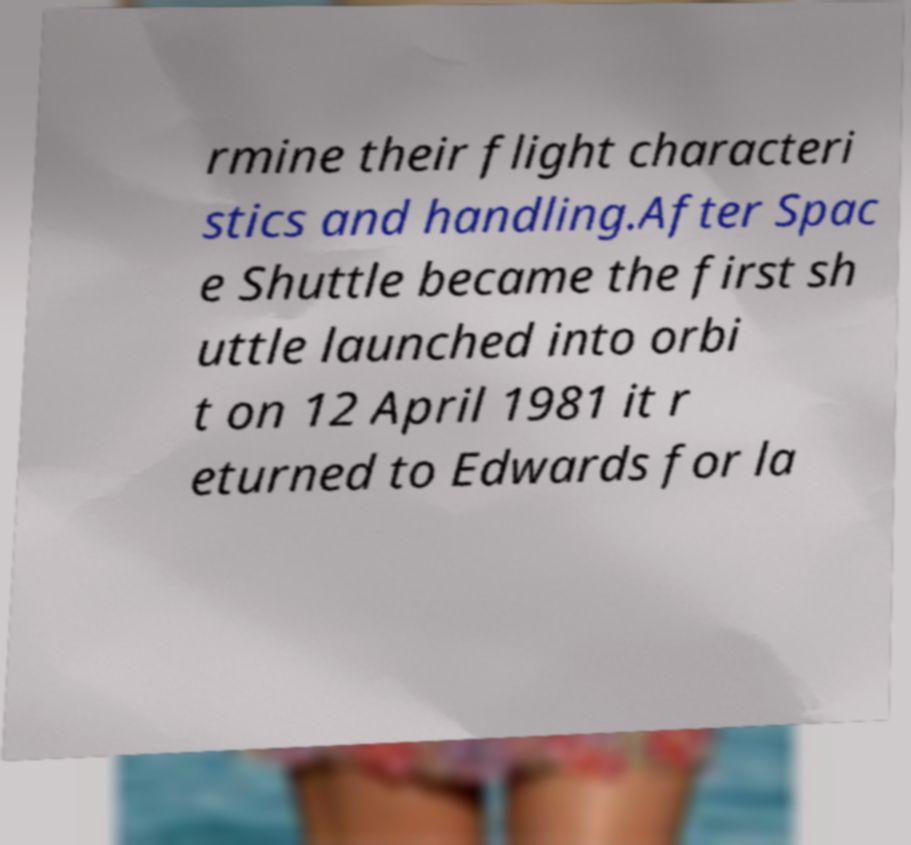I need the written content from this picture converted into text. Can you do that? rmine their flight characteri stics and handling.After Spac e Shuttle became the first sh uttle launched into orbi t on 12 April 1981 it r eturned to Edwards for la 